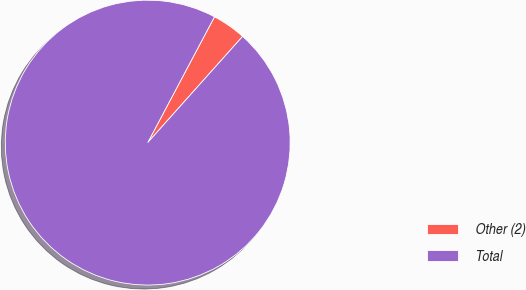Convert chart to OTSL. <chart><loc_0><loc_0><loc_500><loc_500><pie_chart><fcel>Other (2)<fcel>Total<nl><fcel>3.84%<fcel>96.16%<nl></chart> 